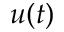Convert formula to latex. <formula><loc_0><loc_0><loc_500><loc_500>u ( t )</formula> 